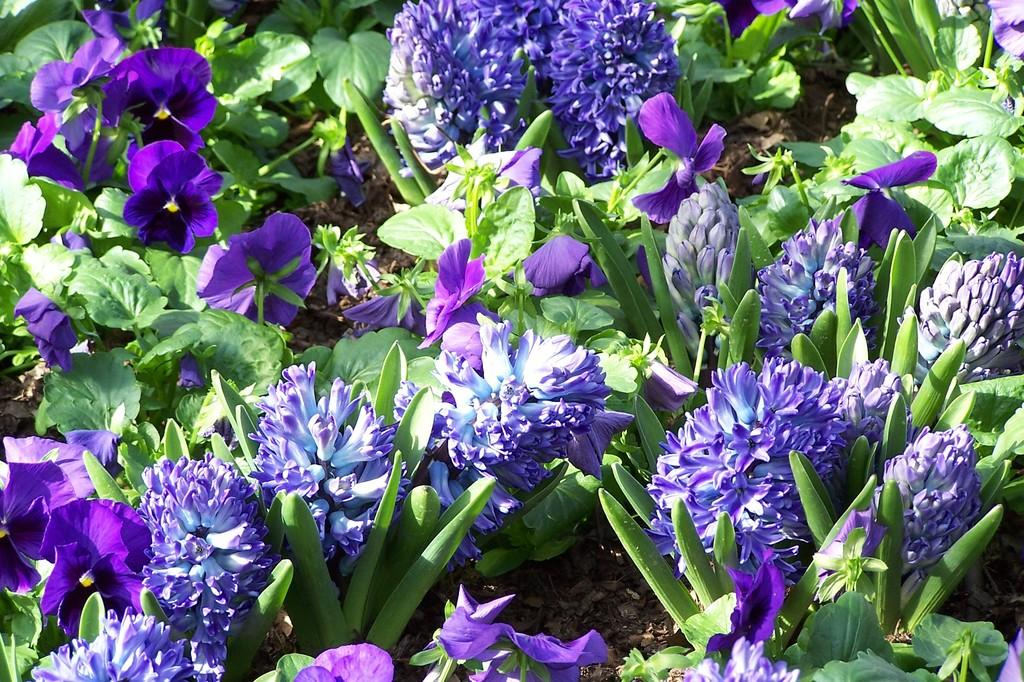What type of plants can be seen in the image? There are flowering plants in the image. Where might this image have been taken? The image is likely taken in a garden. At what time of day was the image likely taken? The image was likely taken during the day. What type of art can be seen on the tail of the bird in the image? There are no birds or tails present in the image, so it is not possible to answer that question. 